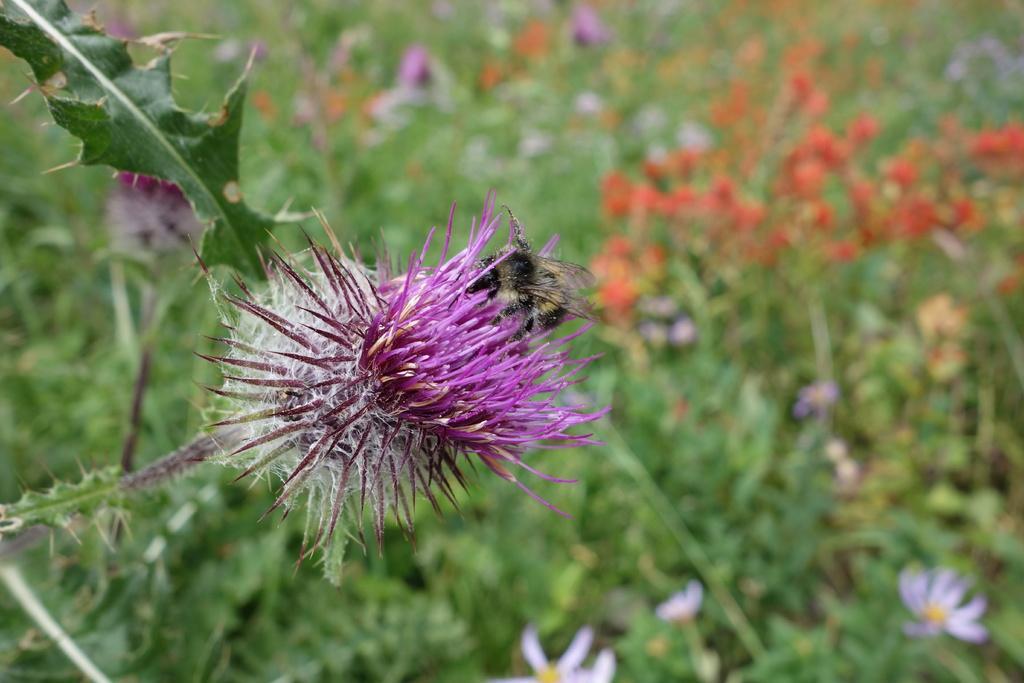Please provide a concise description of this image. In the picture we can see a plant with a pine leaf and flower and behind it, we can see some plants with flowers which are not clearly visible. 